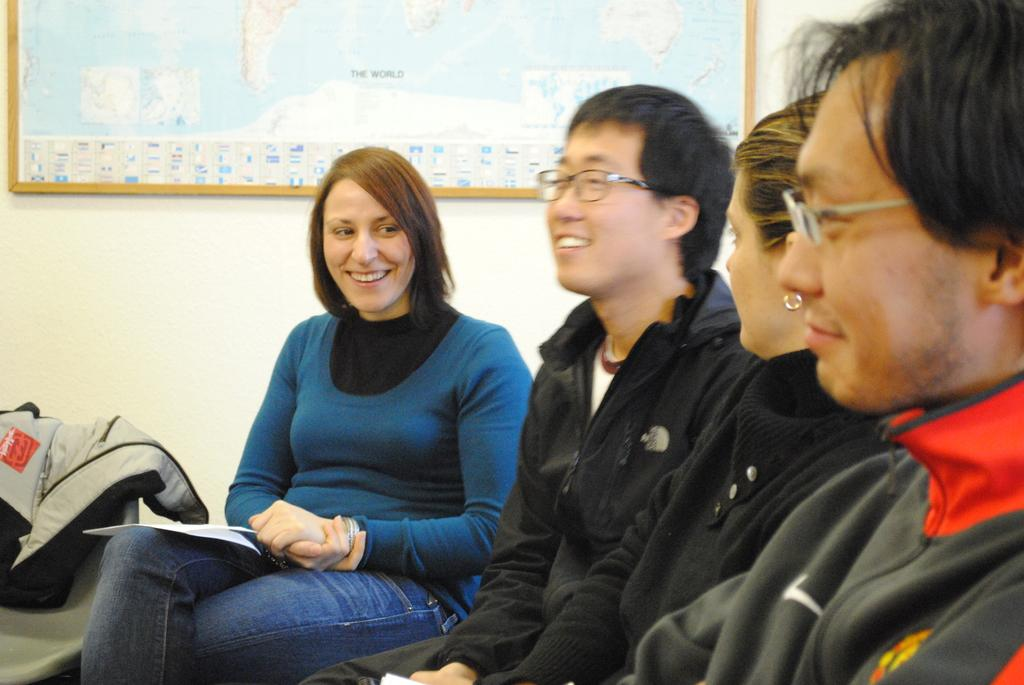What are the people in the image doing? The people in the image are sitting. Can you describe any other objects or features in the image? There is a frame on the wall in the image. What type of bird can be seen sitting on the spade in the image? There is no bird or spade present in the image; it only features people sitting and a frame on the wall. 